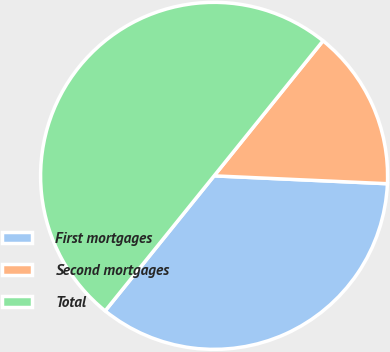Convert chart. <chart><loc_0><loc_0><loc_500><loc_500><pie_chart><fcel>First mortgages<fcel>Second mortgages<fcel>Total<nl><fcel>35.08%<fcel>14.92%<fcel>50.0%<nl></chart> 